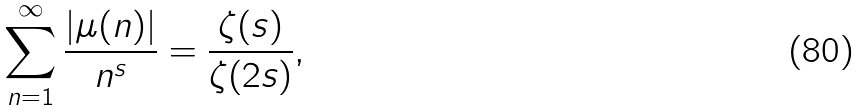Convert formula to latex. <formula><loc_0><loc_0><loc_500><loc_500>\sum _ { n = 1 } ^ { \infty } { \frac { | \mu ( n ) | } { n ^ { s } } } = { \frac { \zeta ( s ) } { \zeta ( 2 s ) } } ,</formula> 